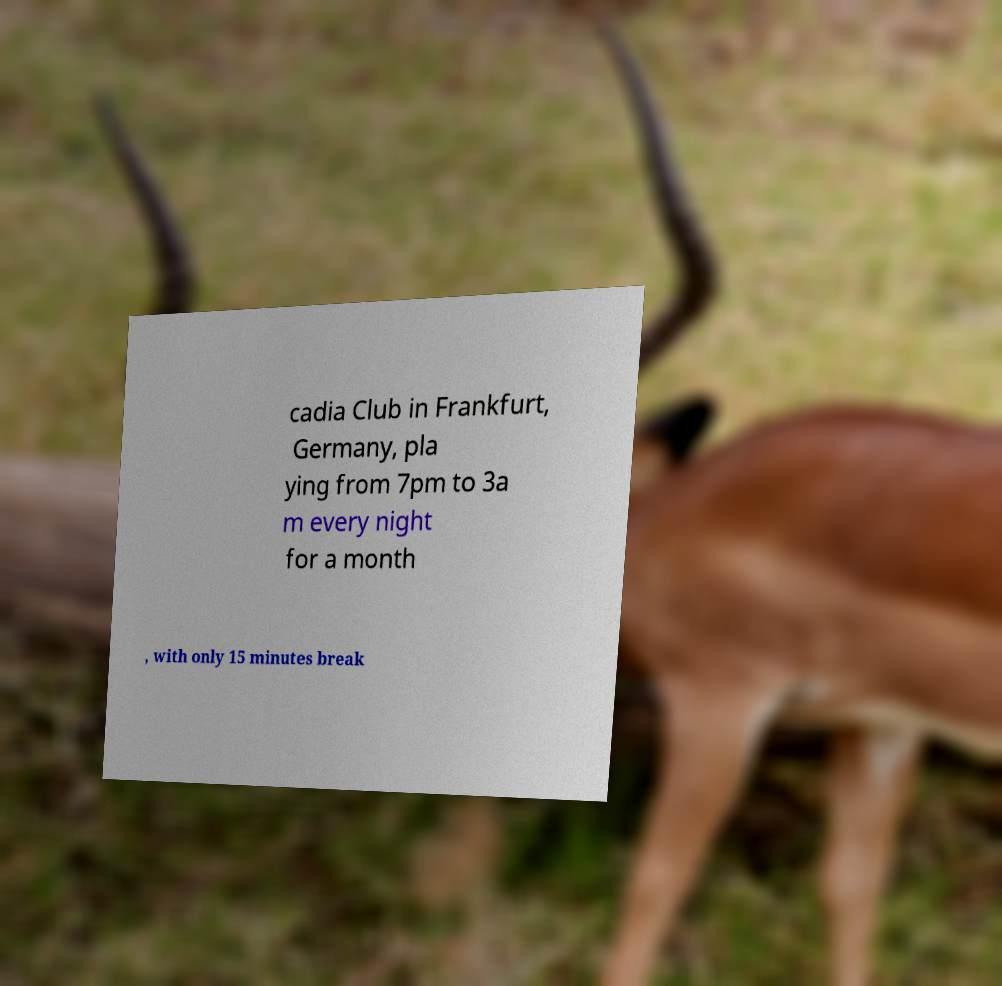Could you assist in decoding the text presented in this image and type it out clearly? cadia Club in Frankfurt, Germany, pla ying from 7pm to 3a m every night for a month , with only 15 minutes break 